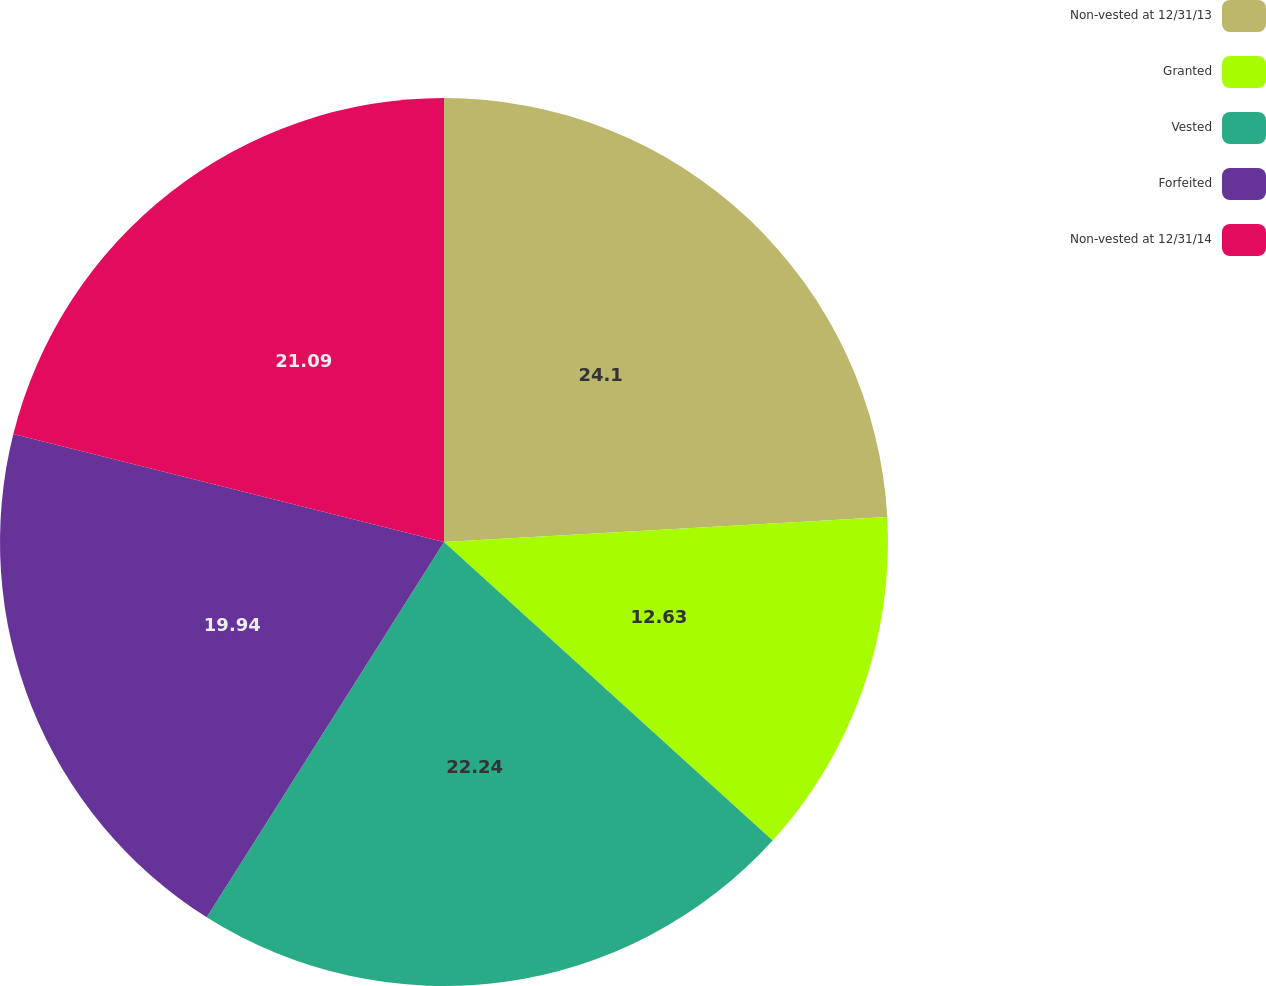Convert chart. <chart><loc_0><loc_0><loc_500><loc_500><pie_chart><fcel>Non-vested at 12/31/13<fcel>Granted<fcel>Vested<fcel>Forfeited<fcel>Non-vested at 12/31/14<nl><fcel>24.11%<fcel>12.63%<fcel>22.24%<fcel>19.94%<fcel>21.09%<nl></chart> 